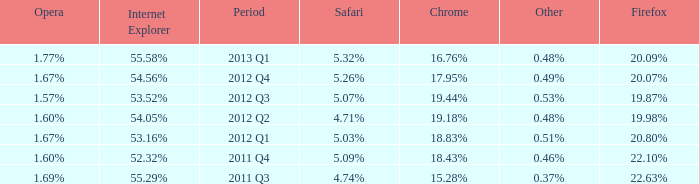What safari has 2012 q4 as the period? 5.26%. 